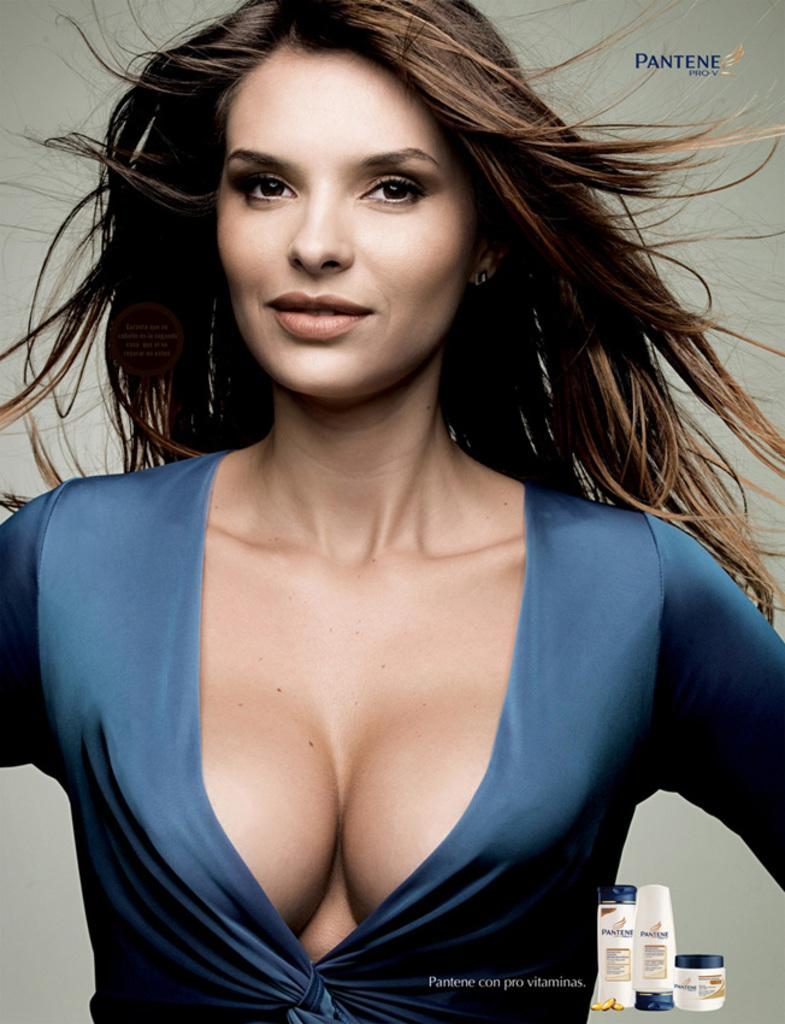Who is present in the image? There is a woman in the image. What is the woman doing in the image? The woman is smiling in the image. What is the woman wearing in the image? The woman is wearing a blue dress in the image. What can be seen in the bottom right side of the image? There are toiletries visible in the bottom right side of the image. What is visible in the background of the image? There is a wall in the background of the image. What type of music is playing in the background of the image? There is no music playing in the background of the image. Is there a sofa visible in the image? No, there is no sofa present in the image. 